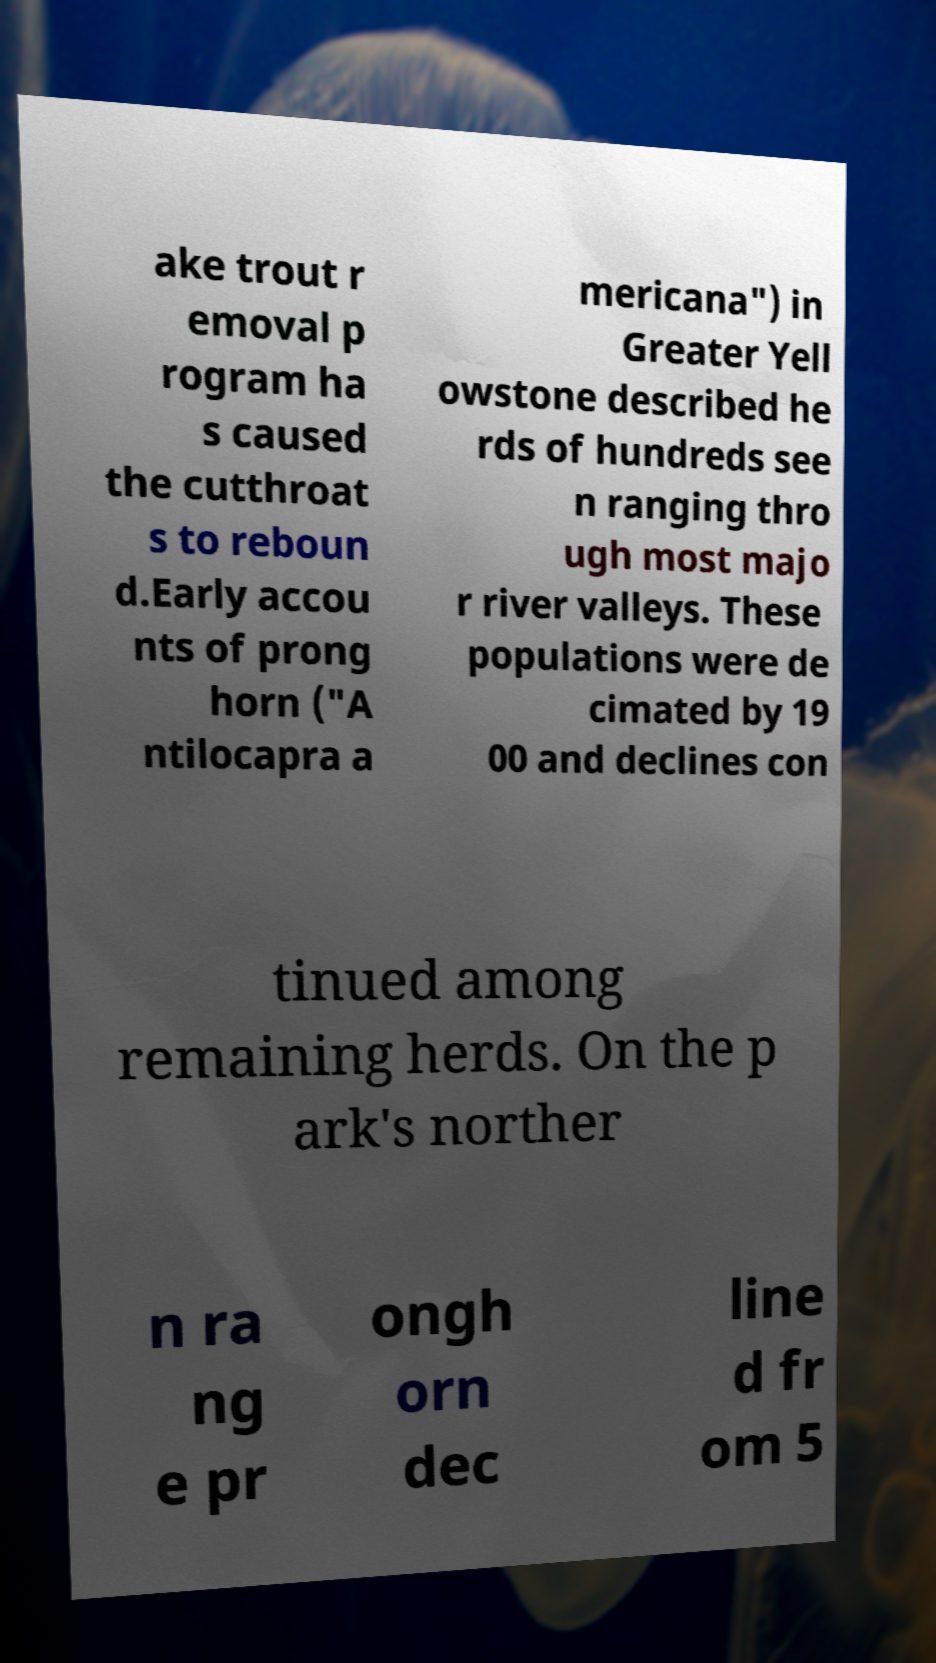There's text embedded in this image that I need extracted. Can you transcribe it verbatim? ake trout r emoval p rogram ha s caused the cutthroat s to reboun d.Early accou nts of prong horn ("A ntilocapra a mericana") in Greater Yell owstone described he rds of hundreds see n ranging thro ugh most majo r river valleys. These populations were de cimated by 19 00 and declines con tinued among remaining herds. On the p ark's norther n ra ng e pr ongh orn dec line d fr om 5 